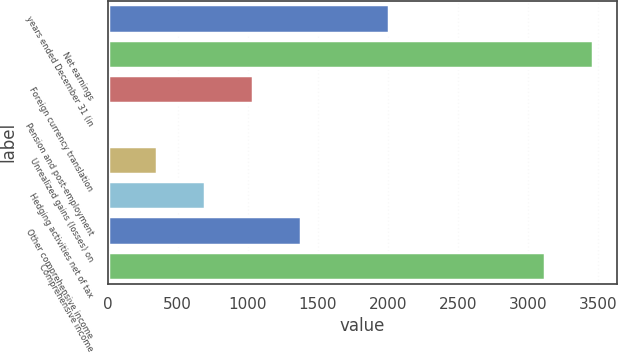Convert chart. <chart><loc_0><loc_0><loc_500><loc_500><bar_chart><fcel>years ended December 31 (in<fcel>Net earnings<fcel>Foreign currency translation<fcel>Pension and post-employment<fcel>Unrealized gains (losses) on<fcel>Hedging activities net of tax<fcel>Other comprehensive income<fcel>Comprehensive income<nl><fcel>2011<fcel>3462.6<fcel>1034.8<fcel>7<fcel>349.6<fcel>692.2<fcel>1377.4<fcel>3120<nl></chart> 